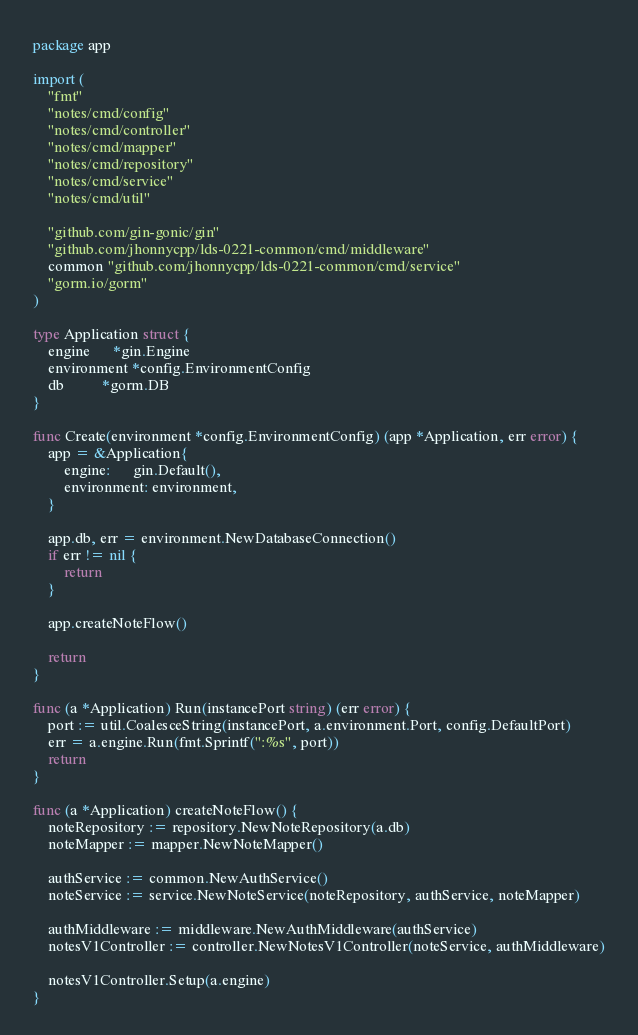Convert code to text. <code><loc_0><loc_0><loc_500><loc_500><_Go_>package app

import (
	"fmt"
	"notes/cmd/config"
	"notes/cmd/controller"
	"notes/cmd/mapper"
	"notes/cmd/repository"
	"notes/cmd/service"
	"notes/cmd/util"

	"github.com/gin-gonic/gin"
	"github.com/jhonnycpp/lds-0221-common/cmd/middleware"
	common "github.com/jhonnycpp/lds-0221-common/cmd/service"
	"gorm.io/gorm"
)

type Application struct {
	engine      *gin.Engine
	environment *config.EnvironmentConfig
	db          *gorm.DB
}

func Create(environment *config.EnvironmentConfig) (app *Application, err error) {
	app = &Application{
		engine:      gin.Default(),
		environment: environment,
	}

	app.db, err = environment.NewDatabaseConnection()
	if err != nil {
		return
	}

	app.createNoteFlow()

	return
}

func (a *Application) Run(instancePort string) (err error) {
	port := util.CoalesceString(instancePort, a.environment.Port, config.DefaultPort)
	err = a.engine.Run(fmt.Sprintf(":%s", port))
	return
}

func (a *Application) createNoteFlow() {
	noteRepository := repository.NewNoteRepository(a.db)
	noteMapper := mapper.NewNoteMapper()

	authService := common.NewAuthService()
	noteService := service.NewNoteService(noteRepository, authService, noteMapper)

	authMiddleware := middleware.NewAuthMiddleware(authService)
	notesV1Controller := controller.NewNotesV1Controller(noteService, authMiddleware)

	notesV1Controller.Setup(a.engine)
}
</code> 